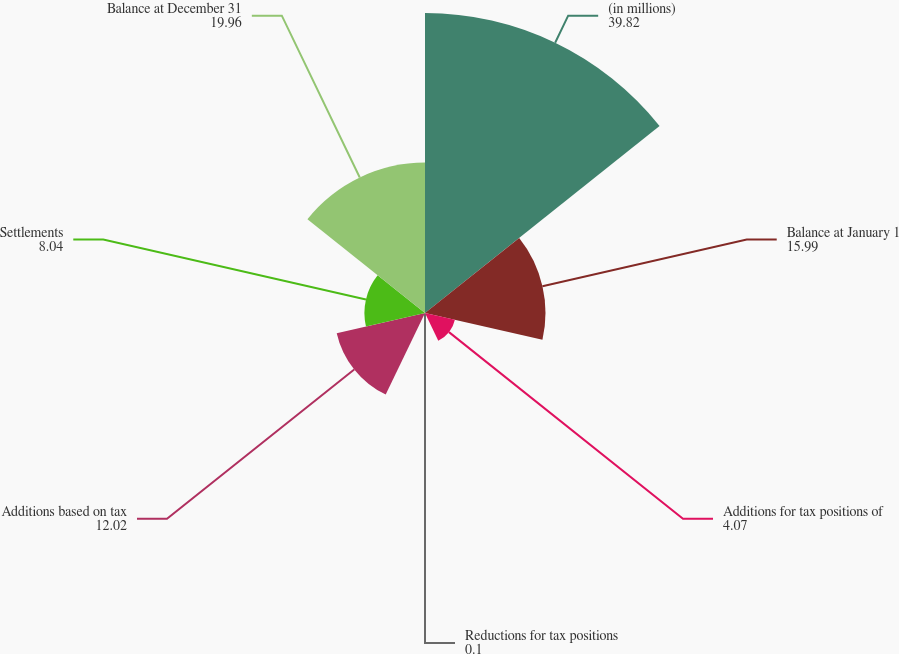<chart> <loc_0><loc_0><loc_500><loc_500><pie_chart><fcel>(in millions)<fcel>Balance at January 1<fcel>Additions for tax positions of<fcel>Reductions for tax positions<fcel>Additions based on tax<fcel>Settlements<fcel>Balance at December 31<nl><fcel>39.82%<fcel>15.99%<fcel>4.07%<fcel>0.1%<fcel>12.02%<fcel>8.04%<fcel>19.96%<nl></chart> 